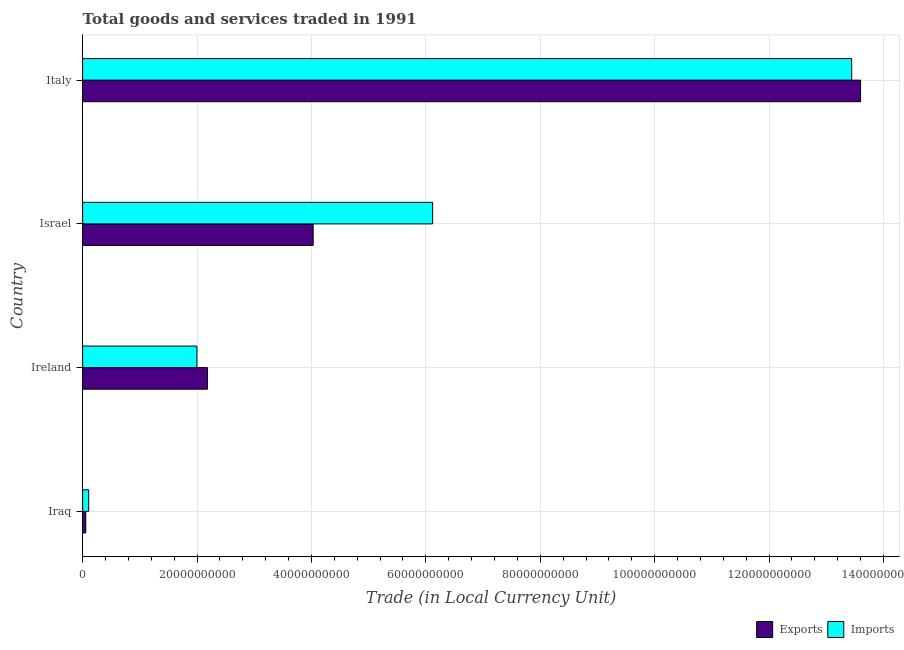How many different coloured bars are there?
Ensure brevity in your answer.  2. Are the number of bars on each tick of the Y-axis equal?
Offer a very short reply. Yes. What is the label of the 2nd group of bars from the top?
Ensure brevity in your answer.  Israel. What is the export of goods and services in Israel?
Ensure brevity in your answer.  4.03e+1. Across all countries, what is the maximum export of goods and services?
Make the answer very short. 1.36e+11. Across all countries, what is the minimum export of goods and services?
Your answer should be compact. 5.48e+08. In which country was the imports of goods and services maximum?
Your answer should be compact. Italy. In which country was the export of goods and services minimum?
Your answer should be compact. Iraq. What is the total export of goods and services in the graph?
Make the answer very short. 1.99e+11. What is the difference between the export of goods and services in Ireland and that in Israel?
Keep it short and to the point. -1.85e+1. What is the difference between the export of goods and services in Israel and the imports of goods and services in Iraq?
Your response must be concise. 3.92e+1. What is the average export of goods and services per country?
Provide a succinct answer. 4.97e+1. What is the difference between the export of goods and services and imports of goods and services in Italy?
Give a very brief answer. 1.56e+09. What is the ratio of the imports of goods and services in Iraq to that in Ireland?
Ensure brevity in your answer.  0.05. Is the imports of goods and services in Ireland less than that in Italy?
Provide a short and direct response. Yes. Is the difference between the export of goods and services in Ireland and Italy greater than the difference between the imports of goods and services in Ireland and Italy?
Keep it short and to the point. Yes. What is the difference between the highest and the second highest imports of goods and services?
Your response must be concise. 7.33e+1. What is the difference between the highest and the lowest imports of goods and services?
Ensure brevity in your answer.  1.33e+11. In how many countries, is the imports of goods and services greater than the average imports of goods and services taken over all countries?
Offer a very short reply. 2. Is the sum of the imports of goods and services in Israel and Italy greater than the maximum export of goods and services across all countries?
Offer a very short reply. Yes. What does the 2nd bar from the top in Italy represents?
Your answer should be very brief. Exports. What does the 1st bar from the bottom in Israel represents?
Offer a very short reply. Exports. How many bars are there?
Provide a succinct answer. 8. Are the values on the major ticks of X-axis written in scientific E-notation?
Your response must be concise. No. Does the graph contain grids?
Offer a terse response. Yes. How many legend labels are there?
Ensure brevity in your answer.  2. What is the title of the graph?
Provide a succinct answer. Total goods and services traded in 1991. What is the label or title of the X-axis?
Make the answer very short. Trade (in Local Currency Unit). What is the label or title of the Y-axis?
Offer a terse response. Country. What is the Trade (in Local Currency Unit) in Exports in Iraq?
Your answer should be very brief. 5.48e+08. What is the Trade (in Local Currency Unit) in Imports in Iraq?
Make the answer very short. 1.06e+09. What is the Trade (in Local Currency Unit) of Exports in Ireland?
Keep it short and to the point. 2.18e+1. What is the Trade (in Local Currency Unit) of Imports in Ireland?
Make the answer very short. 2.00e+1. What is the Trade (in Local Currency Unit) in Exports in Israel?
Your answer should be compact. 4.03e+1. What is the Trade (in Local Currency Unit) in Imports in Israel?
Make the answer very short. 6.12e+1. What is the Trade (in Local Currency Unit) in Exports in Italy?
Offer a very short reply. 1.36e+11. What is the Trade (in Local Currency Unit) in Imports in Italy?
Your answer should be compact. 1.34e+11. Across all countries, what is the maximum Trade (in Local Currency Unit) of Exports?
Ensure brevity in your answer.  1.36e+11. Across all countries, what is the maximum Trade (in Local Currency Unit) of Imports?
Provide a succinct answer. 1.34e+11. Across all countries, what is the minimum Trade (in Local Currency Unit) of Exports?
Your response must be concise. 5.48e+08. Across all countries, what is the minimum Trade (in Local Currency Unit) in Imports?
Provide a succinct answer. 1.06e+09. What is the total Trade (in Local Currency Unit) in Exports in the graph?
Your response must be concise. 1.99e+11. What is the total Trade (in Local Currency Unit) of Imports in the graph?
Your answer should be compact. 2.17e+11. What is the difference between the Trade (in Local Currency Unit) in Exports in Iraq and that in Ireland?
Offer a very short reply. -2.13e+1. What is the difference between the Trade (in Local Currency Unit) in Imports in Iraq and that in Ireland?
Ensure brevity in your answer.  -1.89e+1. What is the difference between the Trade (in Local Currency Unit) of Exports in Iraq and that in Israel?
Give a very brief answer. -3.98e+1. What is the difference between the Trade (in Local Currency Unit) of Imports in Iraq and that in Israel?
Provide a succinct answer. -6.01e+1. What is the difference between the Trade (in Local Currency Unit) in Exports in Iraq and that in Italy?
Keep it short and to the point. -1.35e+11. What is the difference between the Trade (in Local Currency Unit) in Imports in Iraq and that in Italy?
Give a very brief answer. -1.33e+11. What is the difference between the Trade (in Local Currency Unit) in Exports in Ireland and that in Israel?
Provide a short and direct response. -1.85e+1. What is the difference between the Trade (in Local Currency Unit) of Imports in Ireland and that in Israel?
Ensure brevity in your answer.  -4.12e+1. What is the difference between the Trade (in Local Currency Unit) in Exports in Ireland and that in Italy?
Give a very brief answer. -1.14e+11. What is the difference between the Trade (in Local Currency Unit) of Imports in Ireland and that in Italy?
Make the answer very short. -1.14e+11. What is the difference between the Trade (in Local Currency Unit) in Exports in Israel and that in Italy?
Provide a short and direct response. -9.57e+1. What is the difference between the Trade (in Local Currency Unit) of Imports in Israel and that in Italy?
Provide a succinct answer. -7.33e+1. What is the difference between the Trade (in Local Currency Unit) of Exports in Iraq and the Trade (in Local Currency Unit) of Imports in Ireland?
Offer a very short reply. -1.94e+1. What is the difference between the Trade (in Local Currency Unit) of Exports in Iraq and the Trade (in Local Currency Unit) of Imports in Israel?
Offer a terse response. -6.06e+1. What is the difference between the Trade (in Local Currency Unit) of Exports in Iraq and the Trade (in Local Currency Unit) of Imports in Italy?
Your response must be concise. -1.34e+11. What is the difference between the Trade (in Local Currency Unit) in Exports in Ireland and the Trade (in Local Currency Unit) in Imports in Israel?
Offer a terse response. -3.94e+1. What is the difference between the Trade (in Local Currency Unit) in Exports in Ireland and the Trade (in Local Currency Unit) in Imports in Italy?
Offer a very short reply. -1.13e+11. What is the difference between the Trade (in Local Currency Unit) in Exports in Israel and the Trade (in Local Currency Unit) in Imports in Italy?
Your answer should be compact. -9.41e+1. What is the average Trade (in Local Currency Unit) in Exports per country?
Make the answer very short. 4.97e+1. What is the average Trade (in Local Currency Unit) of Imports per country?
Ensure brevity in your answer.  5.42e+1. What is the difference between the Trade (in Local Currency Unit) in Exports and Trade (in Local Currency Unit) in Imports in Iraq?
Keep it short and to the point. -5.14e+08. What is the difference between the Trade (in Local Currency Unit) of Exports and Trade (in Local Currency Unit) of Imports in Ireland?
Your response must be concise. 1.86e+09. What is the difference between the Trade (in Local Currency Unit) of Exports and Trade (in Local Currency Unit) of Imports in Israel?
Your response must be concise. -2.09e+1. What is the difference between the Trade (in Local Currency Unit) in Exports and Trade (in Local Currency Unit) in Imports in Italy?
Your response must be concise. 1.56e+09. What is the ratio of the Trade (in Local Currency Unit) of Exports in Iraq to that in Ireland?
Provide a succinct answer. 0.03. What is the ratio of the Trade (in Local Currency Unit) in Imports in Iraq to that in Ireland?
Your answer should be very brief. 0.05. What is the ratio of the Trade (in Local Currency Unit) of Exports in Iraq to that in Israel?
Make the answer very short. 0.01. What is the ratio of the Trade (in Local Currency Unit) in Imports in Iraq to that in Israel?
Offer a terse response. 0.02. What is the ratio of the Trade (in Local Currency Unit) in Exports in Iraq to that in Italy?
Your answer should be very brief. 0. What is the ratio of the Trade (in Local Currency Unit) of Imports in Iraq to that in Italy?
Your answer should be compact. 0.01. What is the ratio of the Trade (in Local Currency Unit) in Exports in Ireland to that in Israel?
Offer a very short reply. 0.54. What is the ratio of the Trade (in Local Currency Unit) in Imports in Ireland to that in Israel?
Offer a terse response. 0.33. What is the ratio of the Trade (in Local Currency Unit) of Exports in Ireland to that in Italy?
Offer a terse response. 0.16. What is the ratio of the Trade (in Local Currency Unit) of Imports in Ireland to that in Italy?
Offer a terse response. 0.15. What is the ratio of the Trade (in Local Currency Unit) of Exports in Israel to that in Italy?
Your response must be concise. 0.3. What is the ratio of the Trade (in Local Currency Unit) in Imports in Israel to that in Italy?
Offer a terse response. 0.46. What is the difference between the highest and the second highest Trade (in Local Currency Unit) of Exports?
Your answer should be very brief. 9.57e+1. What is the difference between the highest and the second highest Trade (in Local Currency Unit) of Imports?
Make the answer very short. 7.33e+1. What is the difference between the highest and the lowest Trade (in Local Currency Unit) in Exports?
Offer a terse response. 1.35e+11. What is the difference between the highest and the lowest Trade (in Local Currency Unit) in Imports?
Your answer should be very brief. 1.33e+11. 